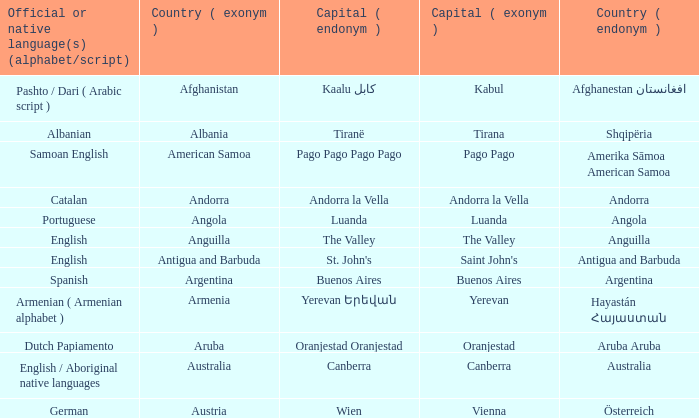What is the local name given to the capital of Anguilla? The Valley. 